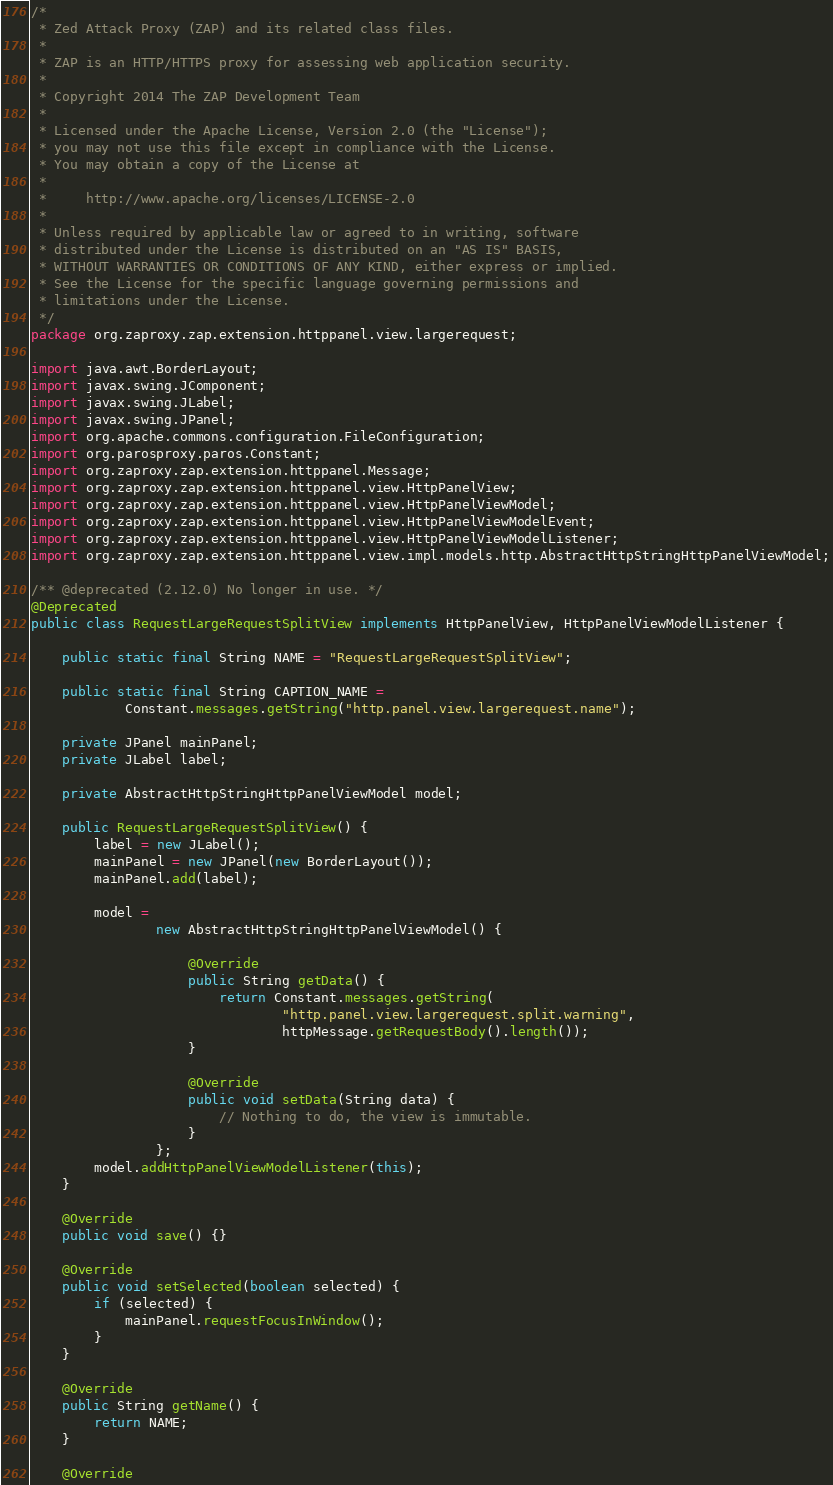<code> <loc_0><loc_0><loc_500><loc_500><_Java_>/*
 * Zed Attack Proxy (ZAP) and its related class files.
 *
 * ZAP is an HTTP/HTTPS proxy for assessing web application security.
 *
 * Copyright 2014 The ZAP Development Team
 *
 * Licensed under the Apache License, Version 2.0 (the "License");
 * you may not use this file except in compliance with the License.
 * You may obtain a copy of the License at
 *
 *     http://www.apache.org/licenses/LICENSE-2.0
 *
 * Unless required by applicable law or agreed to in writing, software
 * distributed under the License is distributed on an "AS IS" BASIS,
 * WITHOUT WARRANTIES OR CONDITIONS OF ANY KIND, either express or implied.
 * See the License for the specific language governing permissions and
 * limitations under the License.
 */
package org.zaproxy.zap.extension.httppanel.view.largerequest;

import java.awt.BorderLayout;
import javax.swing.JComponent;
import javax.swing.JLabel;
import javax.swing.JPanel;
import org.apache.commons.configuration.FileConfiguration;
import org.parosproxy.paros.Constant;
import org.zaproxy.zap.extension.httppanel.Message;
import org.zaproxy.zap.extension.httppanel.view.HttpPanelView;
import org.zaproxy.zap.extension.httppanel.view.HttpPanelViewModel;
import org.zaproxy.zap.extension.httppanel.view.HttpPanelViewModelEvent;
import org.zaproxy.zap.extension.httppanel.view.HttpPanelViewModelListener;
import org.zaproxy.zap.extension.httppanel.view.impl.models.http.AbstractHttpStringHttpPanelViewModel;

/** @deprecated (2.12.0) No longer in use. */
@Deprecated
public class RequestLargeRequestSplitView implements HttpPanelView, HttpPanelViewModelListener {

    public static final String NAME = "RequestLargeRequestSplitView";

    public static final String CAPTION_NAME =
            Constant.messages.getString("http.panel.view.largerequest.name");

    private JPanel mainPanel;
    private JLabel label;

    private AbstractHttpStringHttpPanelViewModel model;

    public RequestLargeRequestSplitView() {
        label = new JLabel();
        mainPanel = new JPanel(new BorderLayout());
        mainPanel.add(label);

        model =
                new AbstractHttpStringHttpPanelViewModel() {

                    @Override
                    public String getData() {
                        return Constant.messages.getString(
                                "http.panel.view.largerequest.split.warning",
                                httpMessage.getRequestBody().length());
                    }

                    @Override
                    public void setData(String data) {
                        // Nothing to do, the view is immutable.
                    }
                };
        model.addHttpPanelViewModelListener(this);
    }

    @Override
    public void save() {}

    @Override
    public void setSelected(boolean selected) {
        if (selected) {
            mainPanel.requestFocusInWindow();
        }
    }

    @Override
    public String getName() {
        return NAME;
    }

    @Override</code> 